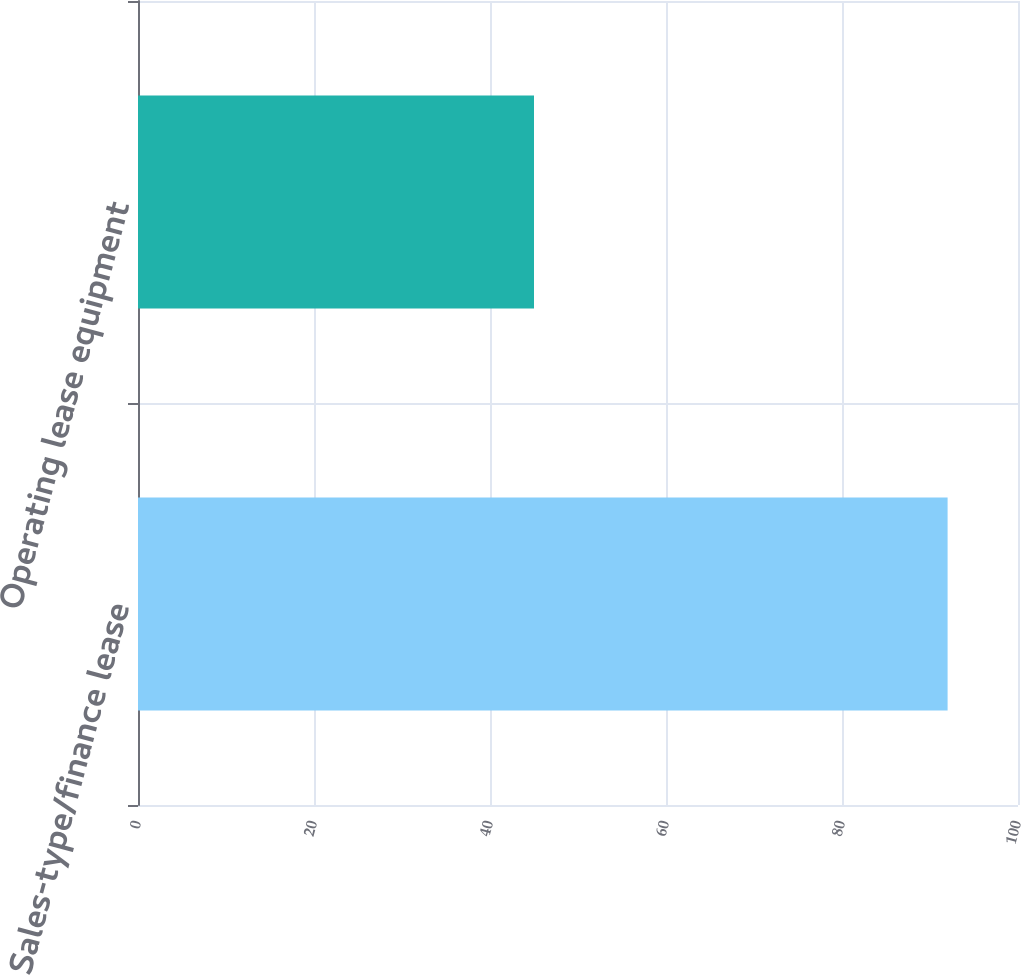Convert chart to OTSL. <chart><loc_0><loc_0><loc_500><loc_500><bar_chart><fcel>Sales-type/finance lease<fcel>Operating lease equipment<nl><fcel>92<fcel>45<nl></chart> 